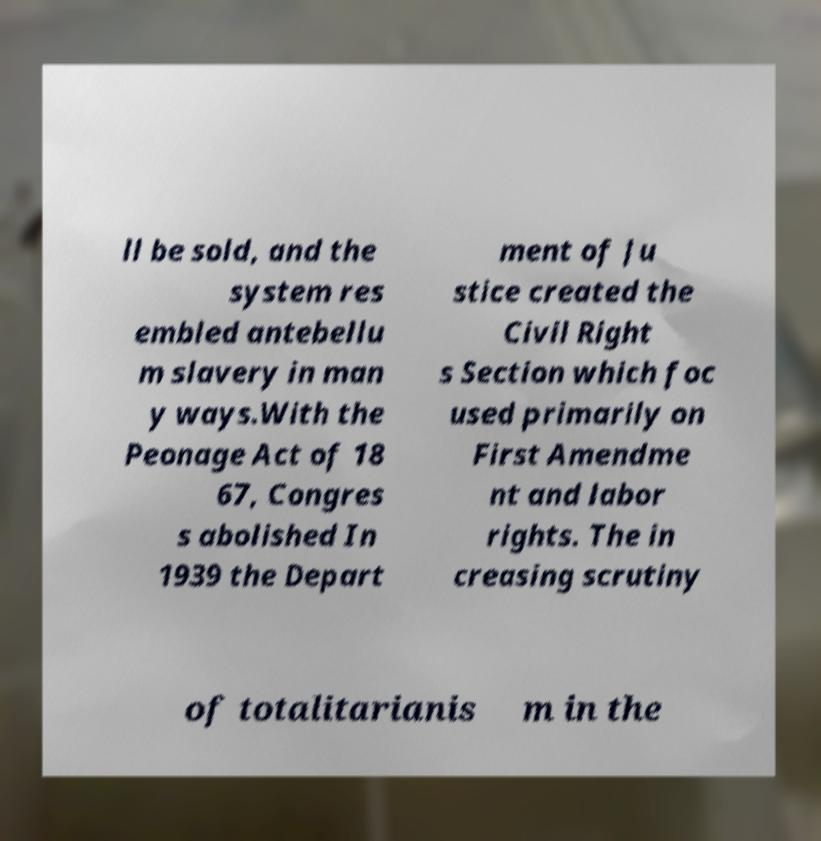What messages or text are displayed in this image? I need them in a readable, typed format. ll be sold, and the system res embled antebellu m slavery in man y ways.With the Peonage Act of 18 67, Congres s abolished In 1939 the Depart ment of Ju stice created the Civil Right s Section which foc used primarily on First Amendme nt and labor rights. The in creasing scrutiny of totalitarianis m in the 